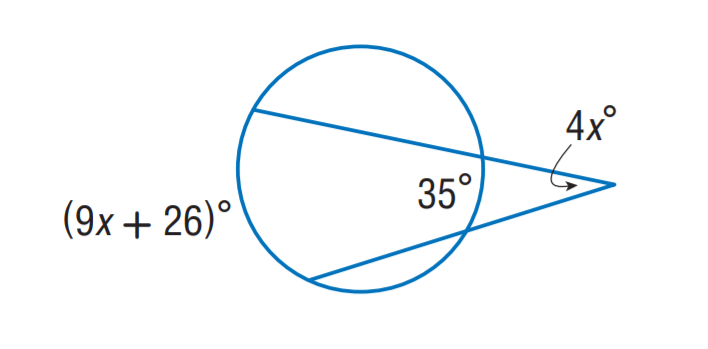Can we determine the size of angles within the circle without knowing x? Without the exact value of x, we can't determine the precise measurement of the angles in the circle, but knowing their relationship — that they are complementary — allows us to understand how they work together geometrically. 